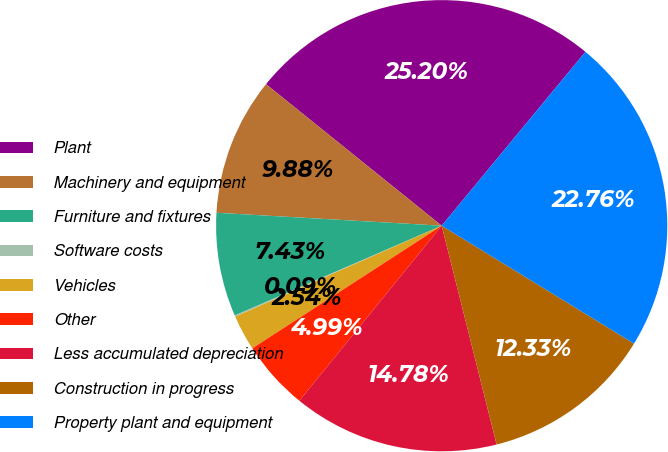Convert chart. <chart><loc_0><loc_0><loc_500><loc_500><pie_chart><fcel>Plant<fcel>Machinery and equipment<fcel>Furniture and fixtures<fcel>Software costs<fcel>Vehicles<fcel>Other<fcel>Less accumulated depreciation<fcel>Construction in progress<fcel>Property plant and equipment<nl><fcel>25.2%<fcel>9.88%<fcel>7.43%<fcel>0.09%<fcel>2.54%<fcel>4.99%<fcel>14.78%<fcel>12.33%<fcel>22.76%<nl></chart> 